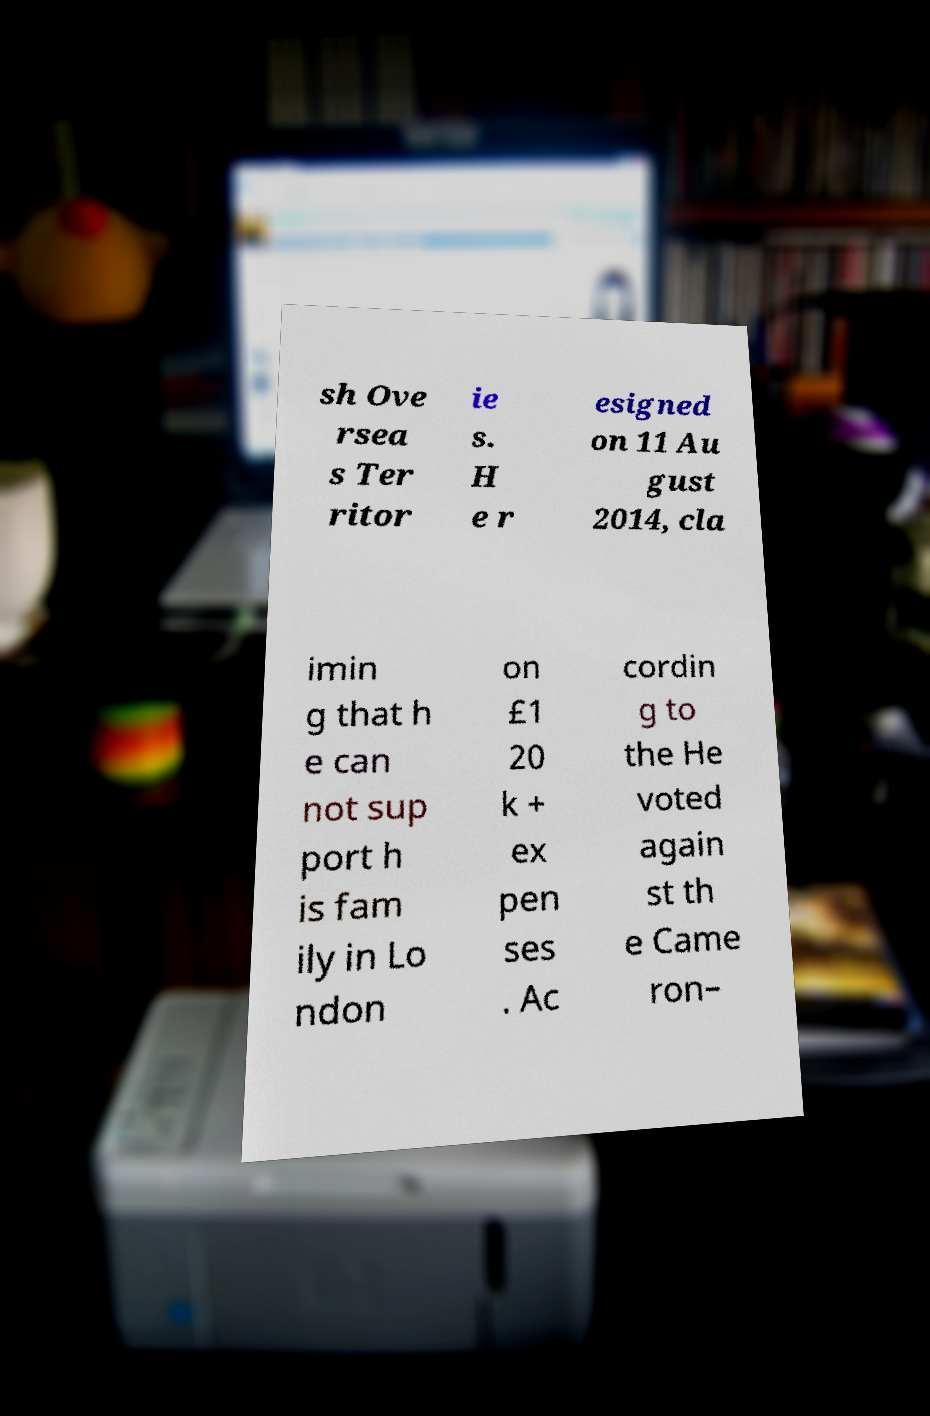There's text embedded in this image that I need extracted. Can you transcribe it verbatim? sh Ove rsea s Ter ritor ie s. H e r esigned on 11 Au gust 2014, cla imin g that h e can not sup port h is fam ily in Lo ndon on £1 20 k + ex pen ses . Ac cordin g to the He voted again st th e Came ron– 